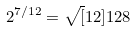<formula> <loc_0><loc_0><loc_500><loc_500>2 ^ { 7 / 1 2 } = \sqrt { [ } 1 2 ] { 1 2 8 }</formula> 